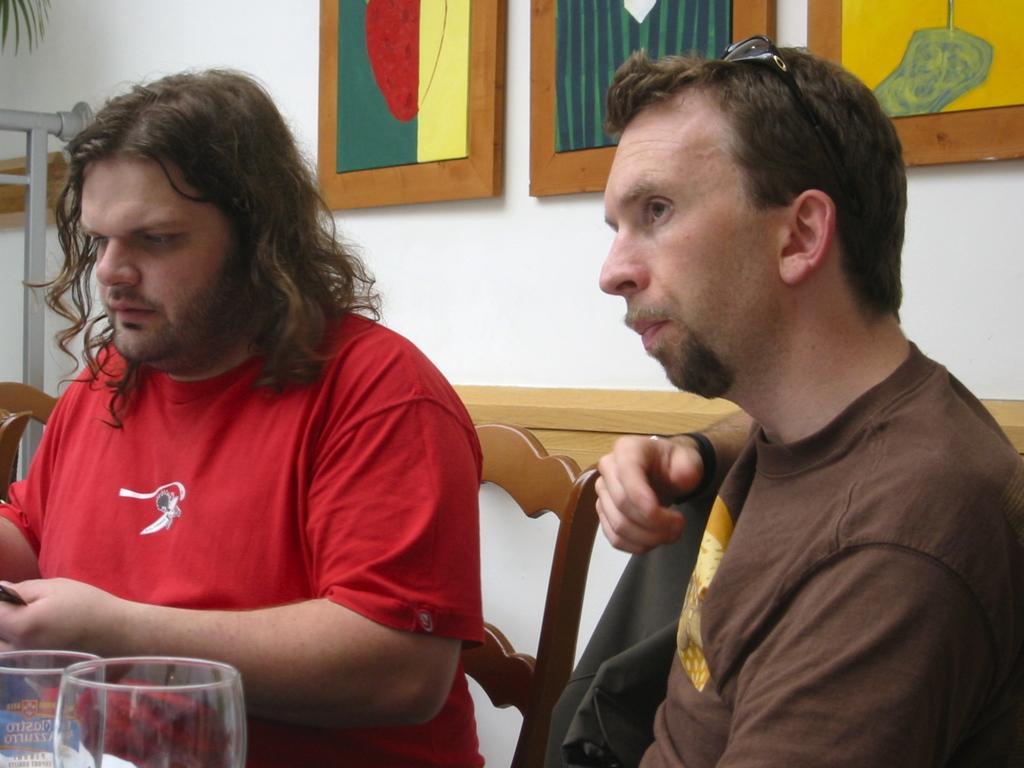Can you describe this image briefly? In the image in the center we can see two persons were sitting on the chair. And on the left bottom,we can see two wine glasses. In the background there is a wall,photo frames,fence,plant and few other objects. 